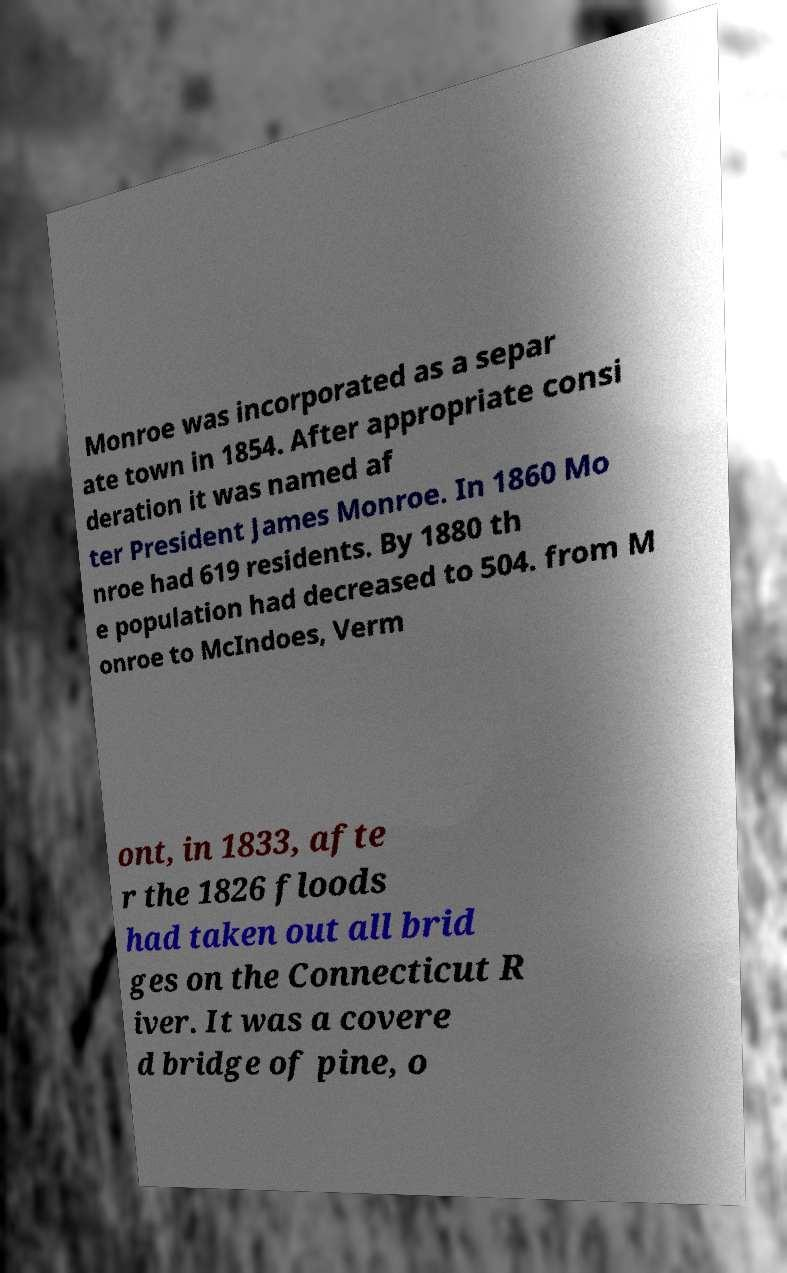There's text embedded in this image that I need extracted. Can you transcribe it verbatim? Monroe was incorporated as a separ ate town in 1854. After appropriate consi deration it was named af ter President James Monroe. In 1860 Mo nroe had 619 residents. By 1880 th e population had decreased to 504. from M onroe to McIndoes, Verm ont, in 1833, afte r the 1826 floods had taken out all brid ges on the Connecticut R iver. It was a covere d bridge of pine, o 